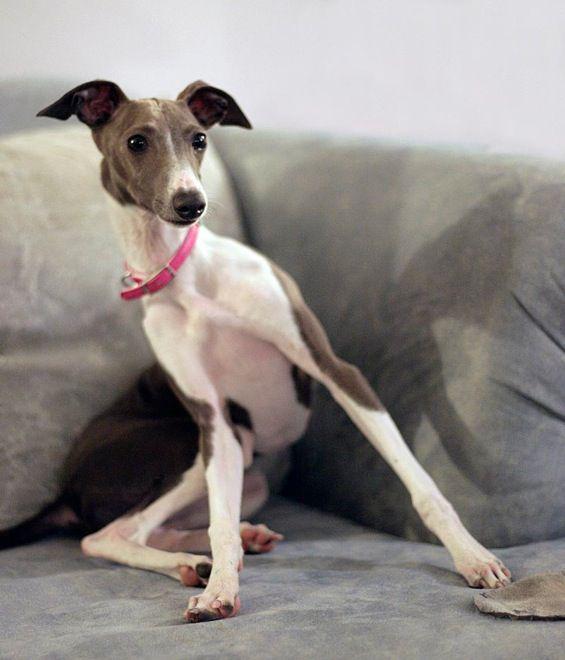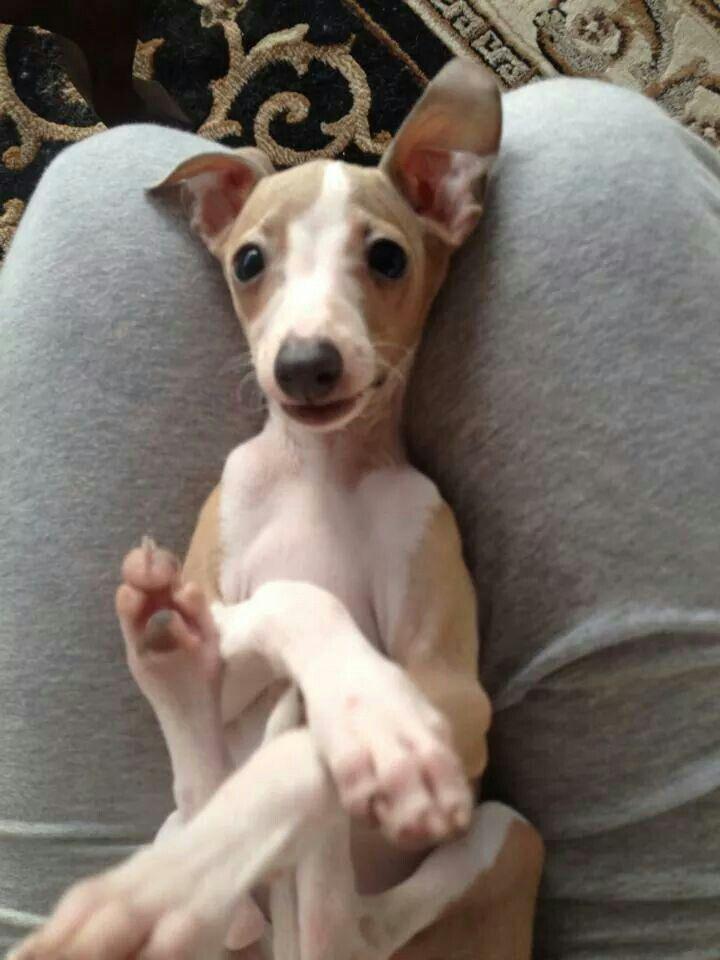The first image is the image on the left, the second image is the image on the right. Assess this claim about the two images: "The right image contains twice as many hound dogs as the left image.". Correct or not? Answer yes or no. No. The first image is the image on the left, the second image is the image on the right. Assess this claim about the two images: "Two dogs are sitting next to each other in the image on the right.". Correct or not? Answer yes or no. No. 